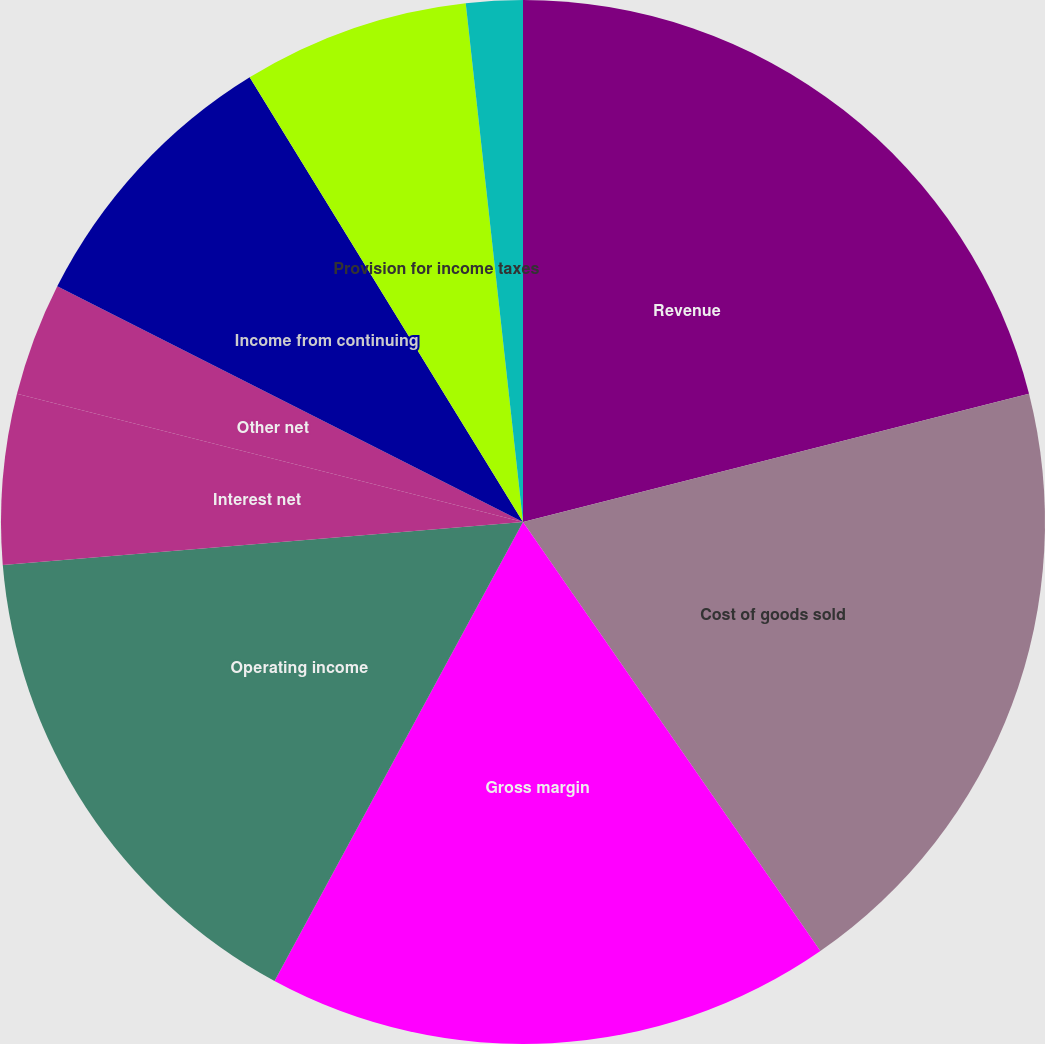<chart> <loc_0><loc_0><loc_500><loc_500><pie_chart><fcel>Revenue<fcel>Cost of goods sold<fcel>Gross margin<fcel>Operating income<fcel>Interest net<fcel>Other net<fcel>Income from continuing<fcel>Provision for income taxes<fcel>Basic earnings per share from<nl><fcel>21.05%<fcel>19.3%<fcel>17.54%<fcel>15.79%<fcel>5.26%<fcel>3.51%<fcel>8.77%<fcel>7.02%<fcel>1.75%<nl></chart> 